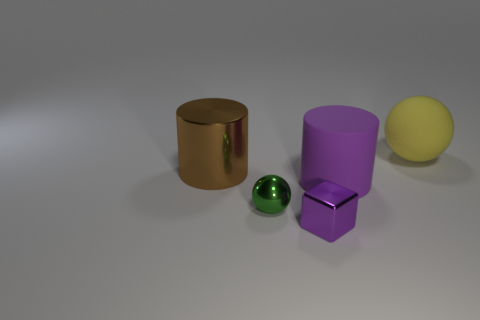Add 5 cyan metallic cubes. How many objects exist? 10 Subtract all balls. How many objects are left? 3 Add 5 brown things. How many brown things are left? 6 Add 4 large cyan matte cylinders. How many large cyan matte cylinders exist? 4 Subtract 1 yellow balls. How many objects are left? 4 Subtract all purple rubber cylinders. Subtract all tiny red metal cubes. How many objects are left? 4 